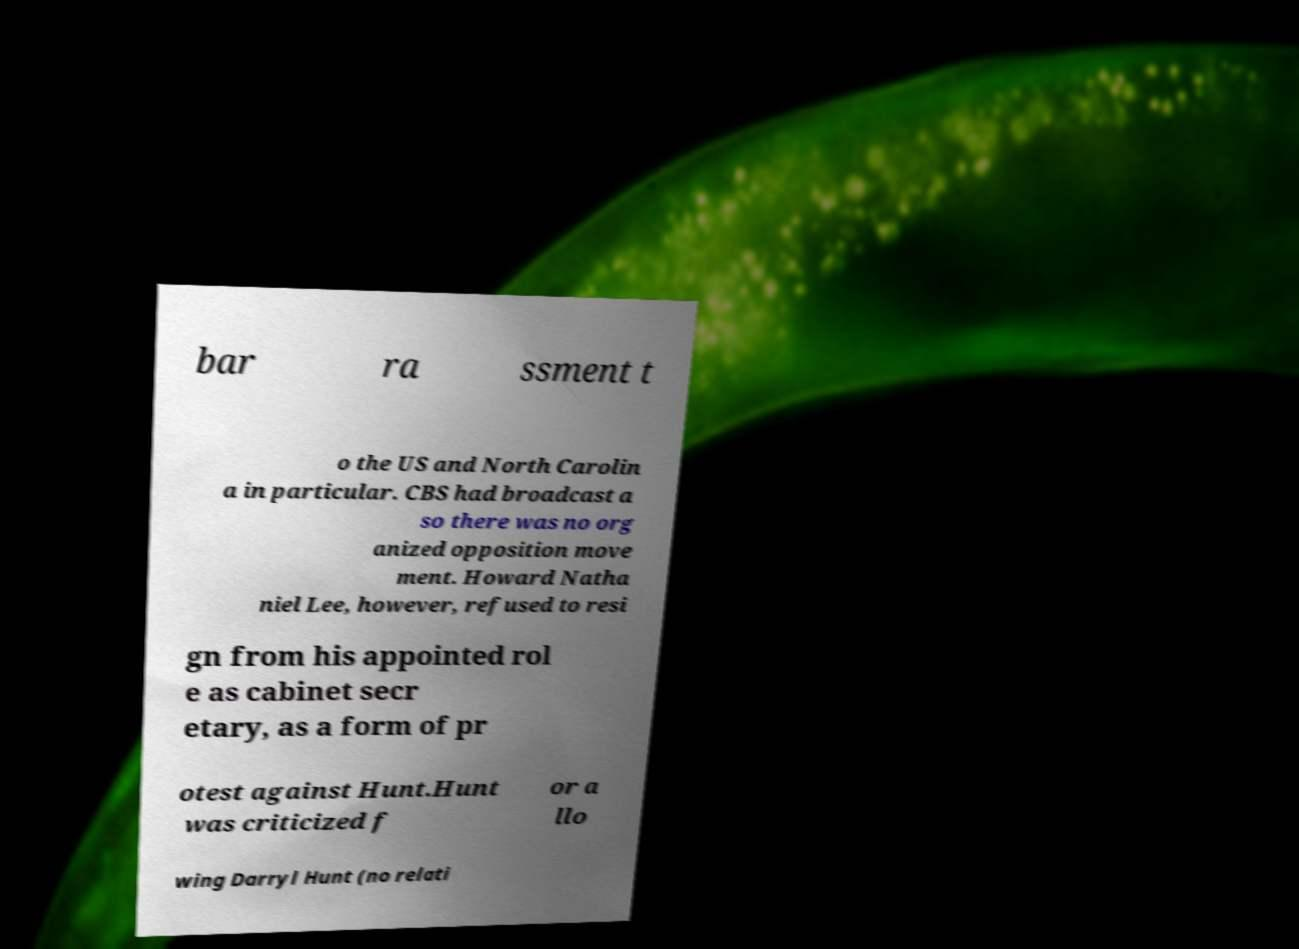What messages or text are displayed in this image? I need them in a readable, typed format. bar ra ssment t o the US and North Carolin a in particular. CBS had broadcast a so there was no org anized opposition move ment. Howard Natha niel Lee, however, refused to resi gn from his appointed rol e as cabinet secr etary, as a form of pr otest against Hunt.Hunt was criticized f or a llo wing Darryl Hunt (no relati 